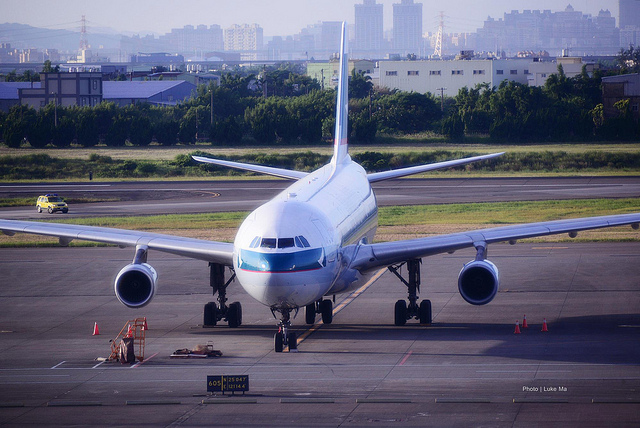Extract all visible text content from this image. Like Me 